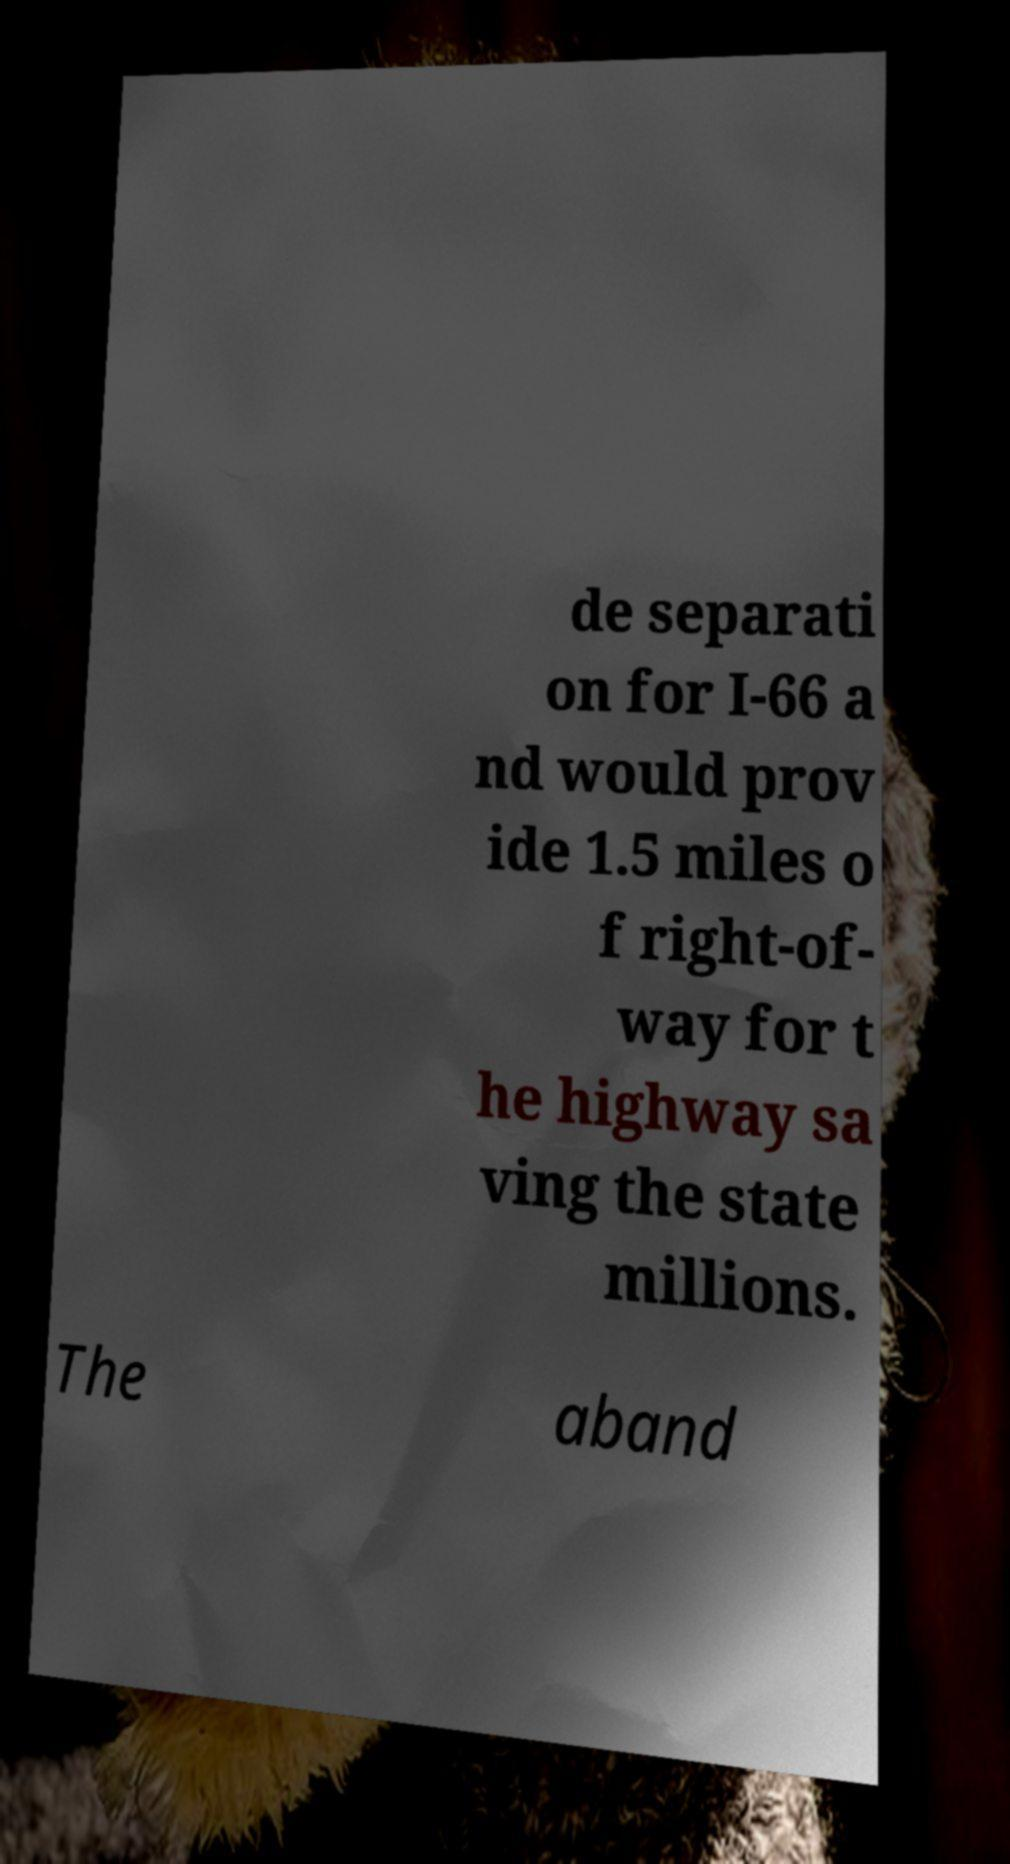Please read and relay the text visible in this image. What does it say? de separati on for I-66 a nd would prov ide 1.5 miles o f right-of- way for t he highway sa ving the state millions. The aband 